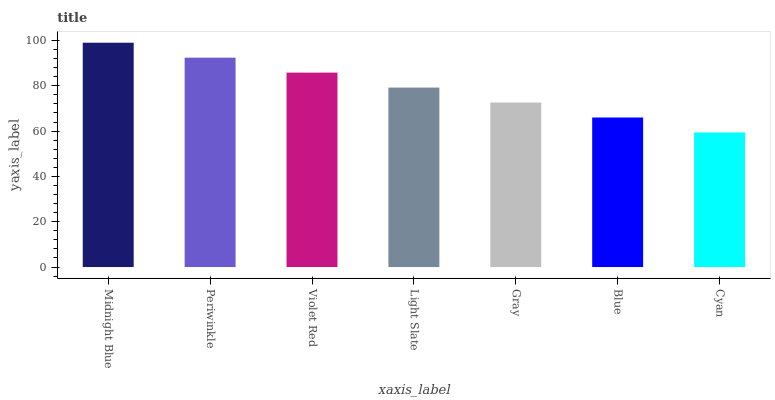Is Cyan the minimum?
Answer yes or no. Yes. Is Midnight Blue the maximum?
Answer yes or no. Yes. Is Periwinkle the minimum?
Answer yes or no. No. Is Periwinkle the maximum?
Answer yes or no. No. Is Midnight Blue greater than Periwinkle?
Answer yes or no. Yes. Is Periwinkle less than Midnight Blue?
Answer yes or no. Yes. Is Periwinkle greater than Midnight Blue?
Answer yes or no. No. Is Midnight Blue less than Periwinkle?
Answer yes or no. No. Is Light Slate the high median?
Answer yes or no. Yes. Is Light Slate the low median?
Answer yes or no. Yes. Is Violet Red the high median?
Answer yes or no. No. Is Blue the low median?
Answer yes or no. No. 